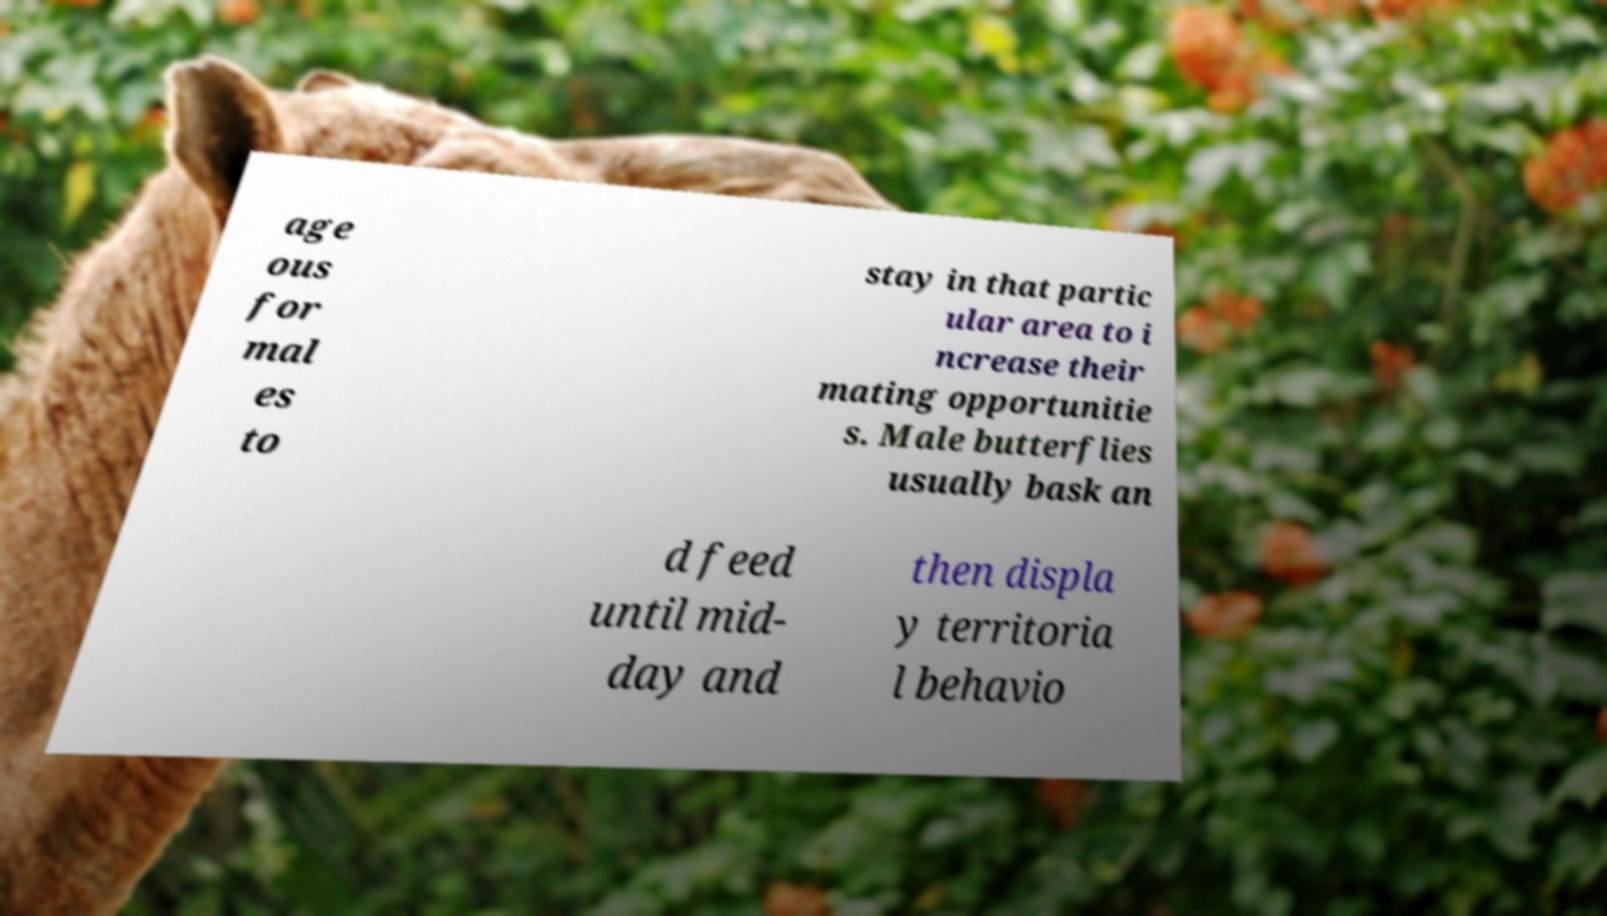For documentation purposes, I need the text within this image transcribed. Could you provide that? age ous for mal es to stay in that partic ular area to i ncrease their mating opportunitie s. Male butterflies usually bask an d feed until mid- day and then displa y territoria l behavio 